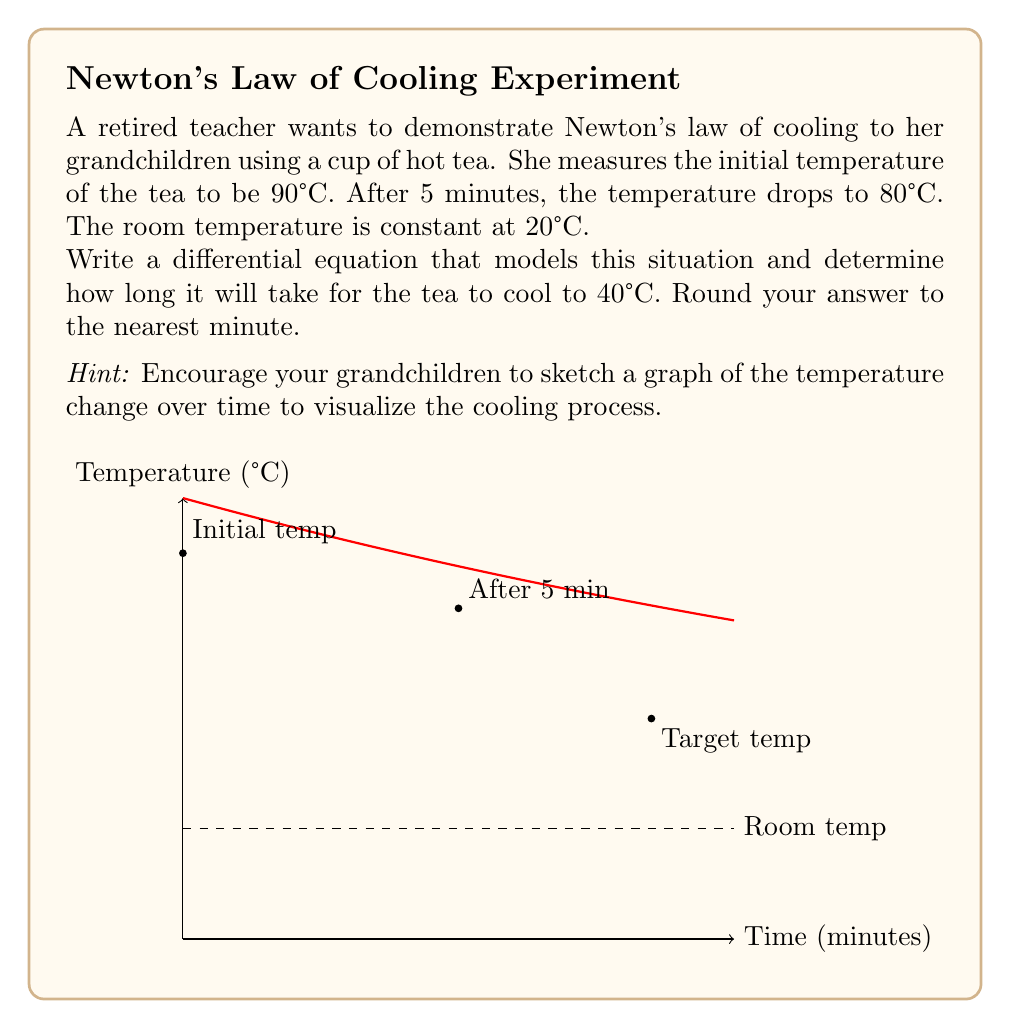Could you help me with this problem? Let's approach this step-by-step:

1) Newton's law of cooling states that the rate of change of the temperature of an object is proportional to the difference between its temperature and the ambient temperature. We can express this as:

   $$\frac{dT}{dt} = -k(T - T_a)$$

   where $T$ is the temperature of the object, $T_a$ is the ambient temperature, $t$ is time, and $k$ is the cooling constant.

2) We know:
   - Initial temperature $T_0 = 90°C$
   - Room temperature $T_a = 20°C$
   - After 5 minutes, $T = 80°C$

3) We need to find $k$ first. The solution to the differential equation is:

   $$T = T_a + (T_0 - T_a)e^{-kt}$$

4) Substituting the known values:

   $$80 = 20 + (90 - 20)e^{-5k}$$
   $$60 = 70e^{-5k}$$

5) Solving for $k$:

   $$\ln(\frac{60}{70}) = -5k$$
   $$k = -\frac{1}{5}\ln(\frac{60}{70}) \approx 0.0462$$

6) Now we can use this value of $k$ to find the time when $T = 40°C$:

   $$40 = 20 + (90 - 20)e^{-0.0462t}$$
   $$20 = 70e^{-0.0462t}$$

7) Solving for $t$:

   $$\ln(\frac{20}{70}) = -0.0462t$$
   $$t = -\frac{1}{0.0462}\ln(\frac{20}{70}) \approx 33.8$$

8) Rounding to the nearest minute, we get 34 minutes.
Answer: 34 minutes 